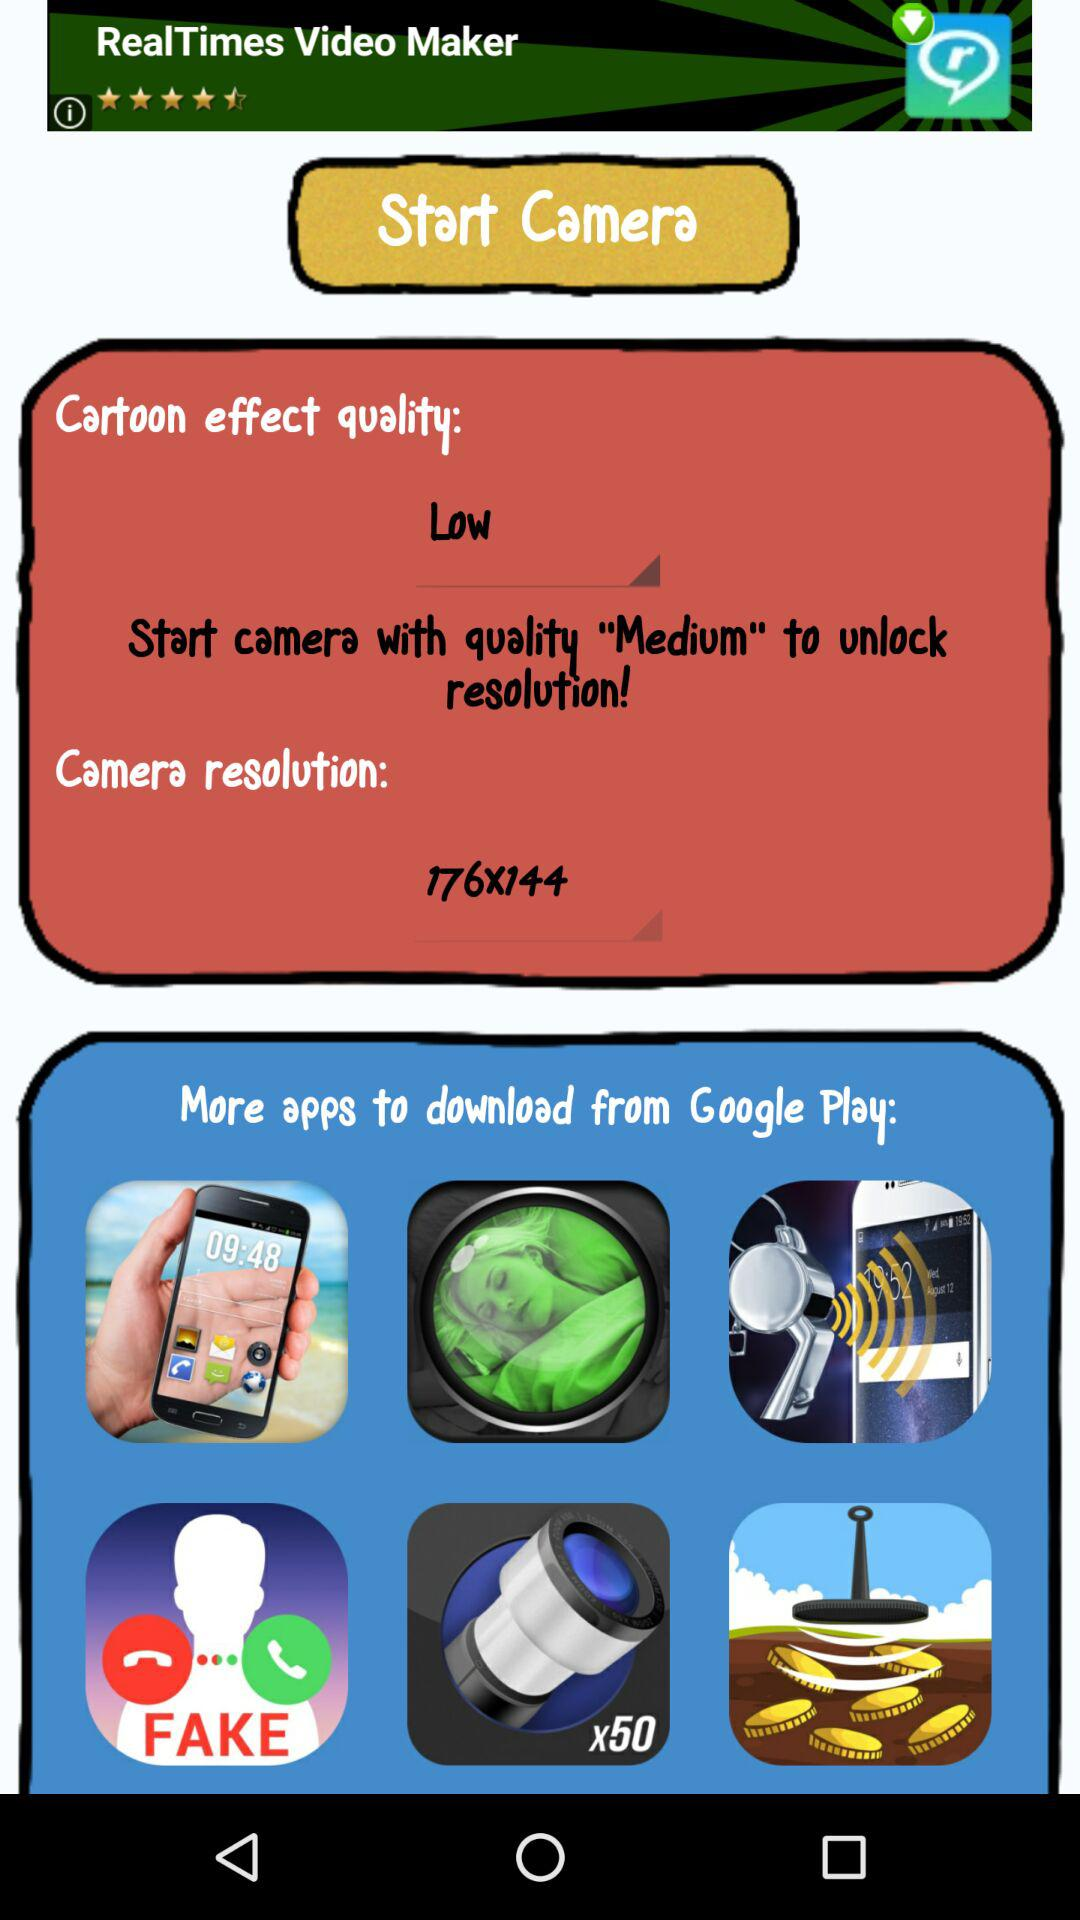What is the selected option for cartoon effect quality? The selected option is "Low". 